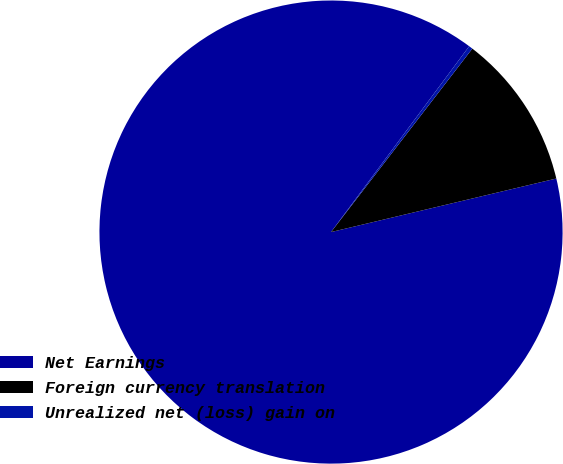<chart> <loc_0><loc_0><loc_500><loc_500><pie_chart><fcel>Net Earnings<fcel>Foreign currency translation<fcel>Unrealized net (loss) gain on<nl><fcel>88.89%<fcel>10.84%<fcel>0.27%<nl></chart> 